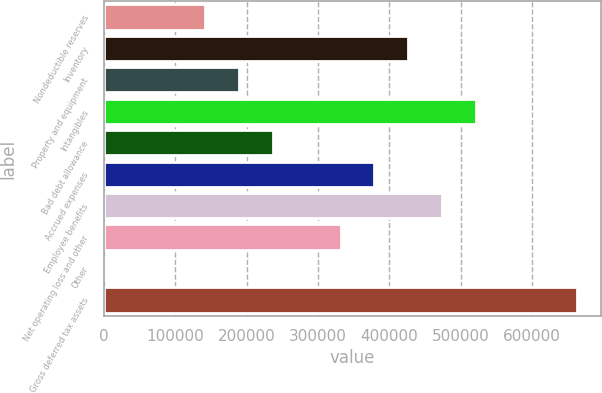Convert chart to OTSL. <chart><loc_0><loc_0><loc_500><loc_500><bar_chart><fcel>Nondeductible reserves<fcel>Inventory<fcel>Property and equipment<fcel>Intangibles<fcel>Bad debt allowance<fcel>Accrued expenses<fcel>Employee benefits<fcel>Net operating loss and other<fcel>Other<fcel>Gross deferred tax assets<nl><fcel>142151<fcel>426308<fcel>189511<fcel>521026<fcel>236870<fcel>378948<fcel>473667<fcel>331589<fcel>73<fcel>663105<nl></chart> 